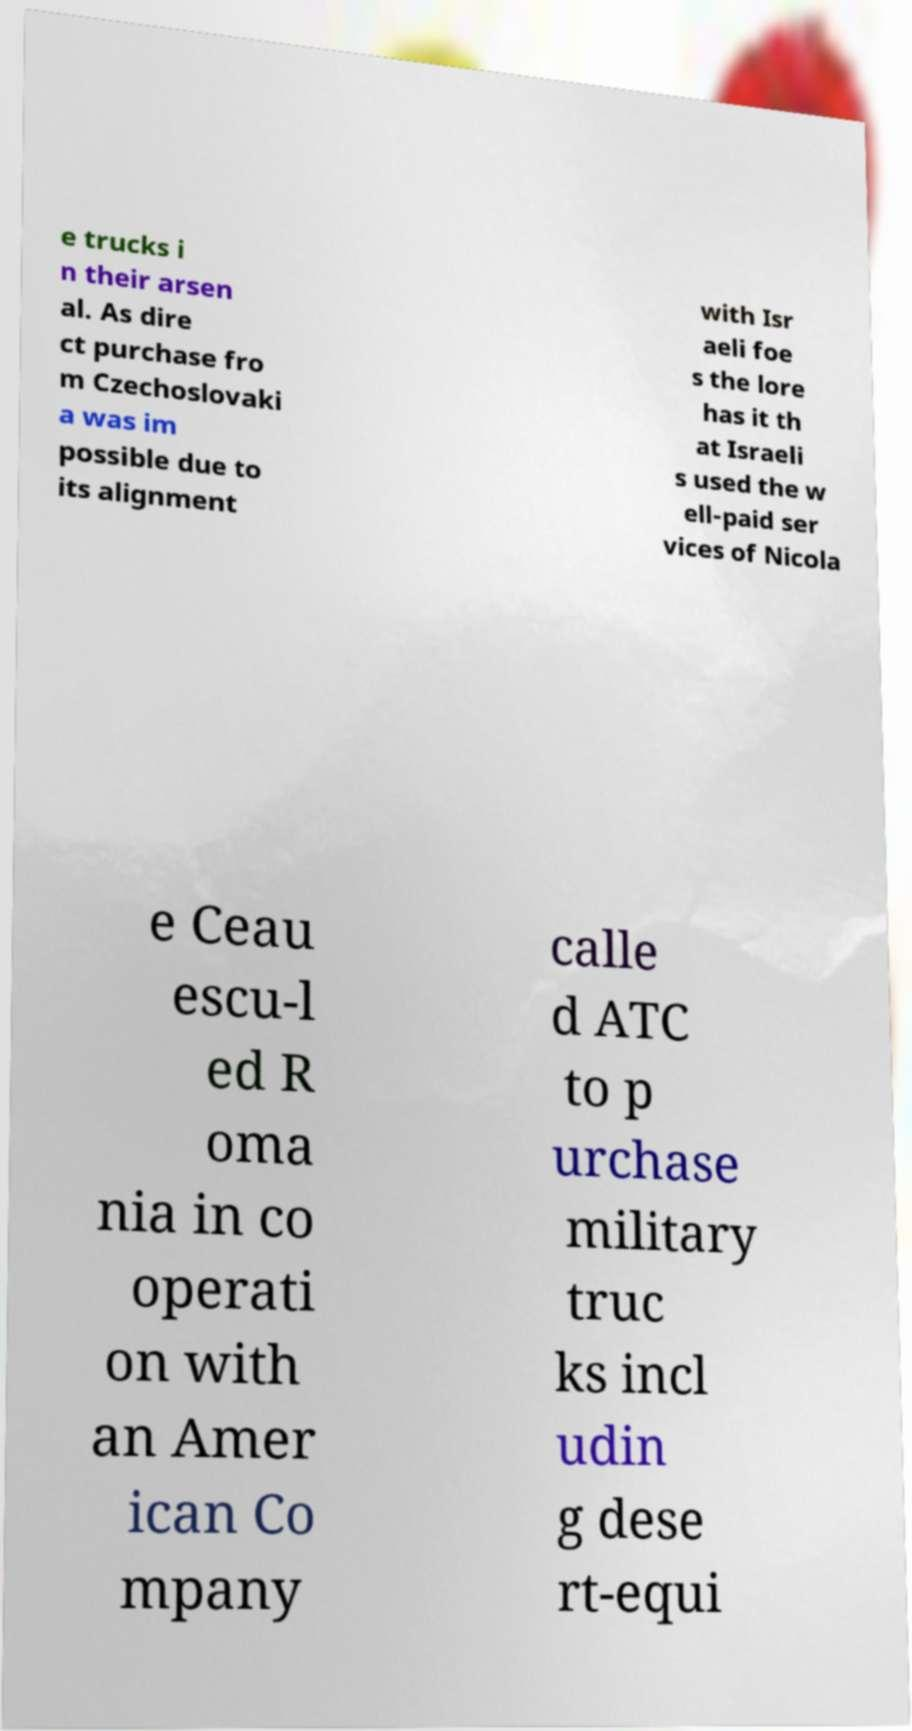Could you assist in decoding the text presented in this image and type it out clearly? e trucks i n their arsen al. As dire ct purchase fro m Czechoslovaki a was im possible due to its alignment with Isr aeli foe s the lore has it th at Israeli s used the w ell-paid ser vices of Nicola e Ceau escu-l ed R oma nia in co operati on with an Amer ican Co mpany calle d ATC to p urchase military truc ks incl udin g dese rt-equi 